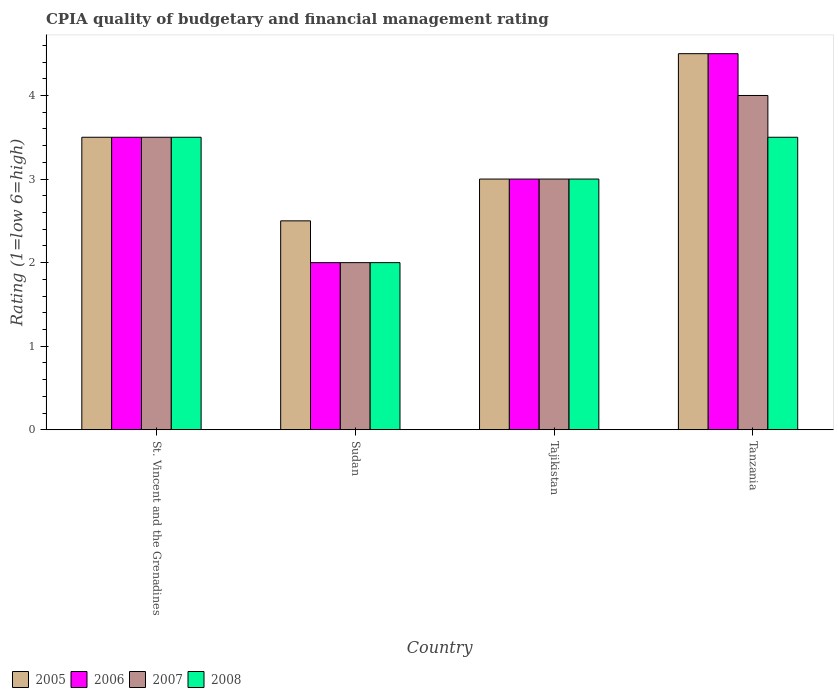How many different coloured bars are there?
Your answer should be compact. 4. How many groups of bars are there?
Your answer should be very brief. 4. Are the number of bars per tick equal to the number of legend labels?
Give a very brief answer. Yes. Are the number of bars on each tick of the X-axis equal?
Give a very brief answer. Yes. How many bars are there on the 2nd tick from the left?
Your answer should be very brief. 4. What is the label of the 1st group of bars from the left?
Provide a short and direct response. St. Vincent and the Grenadines. What is the CPIA rating in 2006 in Tajikistan?
Ensure brevity in your answer.  3. Across all countries, what is the maximum CPIA rating in 2007?
Your answer should be very brief. 4. Across all countries, what is the minimum CPIA rating in 2007?
Your answer should be very brief. 2. In which country was the CPIA rating in 2008 maximum?
Offer a very short reply. St. Vincent and the Grenadines. In which country was the CPIA rating in 2008 minimum?
Your answer should be very brief. Sudan. What is the total CPIA rating in 2008 in the graph?
Ensure brevity in your answer.  12. What is the difference between the CPIA rating in 2006 in Sudan and that in Tajikistan?
Provide a short and direct response. -1. What is the average CPIA rating in 2008 per country?
Your response must be concise. 3. What is the difference between the CPIA rating of/in 2008 and CPIA rating of/in 2006 in Tajikistan?
Your answer should be very brief. 0. In how many countries, is the CPIA rating in 2005 greater than 1.8?
Give a very brief answer. 4. What is the ratio of the CPIA rating in 2006 in Sudan to that in Tajikistan?
Keep it short and to the point. 0.67. Is the difference between the CPIA rating in 2008 in Sudan and Tanzania greater than the difference between the CPIA rating in 2006 in Sudan and Tanzania?
Give a very brief answer. Yes. What is the difference between the highest and the lowest CPIA rating in 2007?
Keep it short and to the point. 2. What does the 4th bar from the left in Sudan represents?
Your answer should be very brief. 2008. What does the 2nd bar from the right in St. Vincent and the Grenadines represents?
Provide a succinct answer. 2007. How many bars are there?
Make the answer very short. 16. What is the difference between two consecutive major ticks on the Y-axis?
Provide a short and direct response. 1. Are the values on the major ticks of Y-axis written in scientific E-notation?
Your answer should be compact. No. Does the graph contain grids?
Offer a terse response. No. Where does the legend appear in the graph?
Make the answer very short. Bottom left. How many legend labels are there?
Keep it short and to the point. 4. What is the title of the graph?
Ensure brevity in your answer.  CPIA quality of budgetary and financial management rating. Does "1993" appear as one of the legend labels in the graph?
Your answer should be very brief. No. What is the label or title of the X-axis?
Offer a terse response. Country. What is the Rating (1=low 6=high) of 2006 in St. Vincent and the Grenadines?
Ensure brevity in your answer.  3.5. What is the Rating (1=low 6=high) in 2007 in St. Vincent and the Grenadines?
Provide a succinct answer. 3.5. What is the Rating (1=low 6=high) in 2005 in Sudan?
Provide a succinct answer. 2.5. What is the Rating (1=low 6=high) of 2006 in Sudan?
Your answer should be very brief. 2. What is the Rating (1=low 6=high) of 2007 in Sudan?
Offer a very short reply. 2. What is the Rating (1=low 6=high) in 2008 in Sudan?
Your answer should be very brief. 2. What is the Rating (1=low 6=high) of 2005 in Tajikistan?
Provide a short and direct response. 3. What is the Rating (1=low 6=high) of 2006 in Tajikistan?
Offer a terse response. 3. What is the Rating (1=low 6=high) of 2008 in Tajikistan?
Your response must be concise. 3. What is the Rating (1=low 6=high) in 2006 in Tanzania?
Offer a very short reply. 4.5. What is the Rating (1=low 6=high) in 2007 in Tanzania?
Give a very brief answer. 4. What is the Rating (1=low 6=high) in 2008 in Tanzania?
Make the answer very short. 3.5. Across all countries, what is the maximum Rating (1=low 6=high) in 2006?
Provide a succinct answer. 4.5. Across all countries, what is the maximum Rating (1=low 6=high) of 2008?
Your response must be concise. 3.5. Across all countries, what is the minimum Rating (1=low 6=high) of 2005?
Ensure brevity in your answer.  2.5. Across all countries, what is the minimum Rating (1=low 6=high) in 2006?
Provide a succinct answer. 2. What is the total Rating (1=low 6=high) of 2007 in the graph?
Make the answer very short. 12.5. What is the difference between the Rating (1=low 6=high) in 2005 in St. Vincent and the Grenadines and that in Sudan?
Make the answer very short. 1. What is the difference between the Rating (1=low 6=high) of 2007 in St. Vincent and the Grenadines and that in Sudan?
Offer a very short reply. 1.5. What is the difference between the Rating (1=low 6=high) of 2008 in St. Vincent and the Grenadines and that in Sudan?
Your answer should be compact. 1.5. What is the difference between the Rating (1=low 6=high) in 2005 in St. Vincent and the Grenadines and that in Tajikistan?
Provide a succinct answer. 0.5. What is the difference between the Rating (1=low 6=high) of 2007 in St. Vincent and the Grenadines and that in Tajikistan?
Make the answer very short. 0.5. What is the difference between the Rating (1=low 6=high) in 2008 in St. Vincent and the Grenadines and that in Tajikistan?
Keep it short and to the point. 0.5. What is the difference between the Rating (1=low 6=high) of 2006 in St. Vincent and the Grenadines and that in Tanzania?
Give a very brief answer. -1. What is the difference between the Rating (1=low 6=high) in 2005 in Sudan and that in Tajikistan?
Ensure brevity in your answer.  -0.5. What is the difference between the Rating (1=low 6=high) of 2007 in Sudan and that in Tajikistan?
Offer a very short reply. -1. What is the difference between the Rating (1=low 6=high) in 2008 in Sudan and that in Tajikistan?
Your answer should be very brief. -1. What is the difference between the Rating (1=low 6=high) in 2005 in Sudan and that in Tanzania?
Make the answer very short. -2. What is the difference between the Rating (1=low 6=high) in 2006 in Sudan and that in Tanzania?
Provide a succinct answer. -2.5. What is the difference between the Rating (1=low 6=high) of 2007 in Sudan and that in Tanzania?
Your response must be concise. -2. What is the difference between the Rating (1=low 6=high) of 2008 in Sudan and that in Tanzania?
Keep it short and to the point. -1.5. What is the difference between the Rating (1=low 6=high) of 2006 in Tajikistan and that in Tanzania?
Provide a short and direct response. -1.5. What is the difference between the Rating (1=low 6=high) in 2007 in Tajikistan and that in Tanzania?
Provide a succinct answer. -1. What is the difference between the Rating (1=low 6=high) of 2008 in Tajikistan and that in Tanzania?
Your response must be concise. -0.5. What is the difference between the Rating (1=low 6=high) of 2005 in St. Vincent and the Grenadines and the Rating (1=low 6=high) of 2006 in Sudan?
Keep it short and to the point. 1.5. What is the difference between the Rating (1=low 6=high) in 2005 in St. Vincent and the Grenadines and the Rating (1=low 6=high) in 2007 in Sudan?
Offer a very short reply. 1.5. What is the difference between the Rating (1=low 6=high) of 2005 in St. Vincent and the Grenadines and the Rating (1=low 6=high) of 2008 in Sudan?
Provide a succinct answer. 1.5. What is the difference between the Rating (1=low 6=high) in 2006 in St. Vincent and the Grenadines and the Rating (1=low 6=high) in 2008 in Sudan?
Keep it short and to the point. 1.5. What is the difference between the Rating (1=low 6=high) in 2007 in St. Vincent and the Grenadines and the Rating (1=low 6=high) in 2008 in Sudan?
Provide a short and direct response. 1.5. What is the difference between the Rating (1=low 6=high) in 2005 in St. Vincent and the Grenadines and the Rating (1=low 6=high) in 2007 in Tajikistan?
Give a very brief answer. 0.5. What is the difference between the Rating (1=low 6=high) in 2005 in St. Vincent and the Grenadines and the Rating (1=low 6=high) in 2008 in Tajikistan?
Ensure brevity in your answer.  0.5. What is the difference between the Rating (1=low 6=high) in 2006 in St. Vincent and the Grenadines and the Rating (1=low 6=high) in 2007 in Tajikistan?
Give a very brief answer. 0.5. What is the difference between the Rating (1=low 6=high) in 2006 in St. Vincent and the Grenadines and the Rating (1=low 6=high) in 2008 in Tajikistan?
Ensure brevity in your answer.  0.5. What is the difference between the Rating (1=low 6=high) in 2005 in St. Vincent and the Grenadines and the Rating (1=low 6=high) in 2006 in Tanzania?
Provide a short and direct response. -1. What is the difference between the Rating (1=low 6=high) of 2005 in St. Vincent and the Grenadines and the Rating (1=low 6=high) of 2008 in Tanzania?
Offer a terse response. 0. What is the difference between the Rating (1=low 6=high) of 2006 in St. Vincent and the Grenadines and the Rating (1=low 6=high) of 2007 in Tanzania?
Provide a succinct answer. -0.5. What is the difference between the Rating (1=low 6=high) of 2006 in St. Vincent and the Grenadines and the Rating (1=low 6=high) of 2008 in Tanzania?
Offer a very short reply. 0. What is the difference between the Rating (1=low 6=high) in 2007 in St. Vincent and the Grenadines and the Rating (1=low 6=high) in 2008 in Tanzania?
Offer a terse response. 0. What is the difference between the Rating (1=low 6=high) in 2005 in Sudan and the Rating (1=low 6=high) in 2006 in Tajikistan?
Ensure brevity in your answer.  -0.5. What is the difference between the Rating (1=low 6=high) of 2005 in Sudan and the Rating (1=low 6=high) of 2008 in Tajikistan?
Offer a terse response. -0.5. What is the difference between the Rating (1=low 6=high) of 2006 in Sudan and the Rating (1=low 6=high) of 2007 in Tajikistan?
Offer a terse response. -1. What is the difference between the Rating (1=low 6=high) of 2005 in Sudan and the Rating (1=low 6=high) of 2006 in Tanzania?
Your answer should be very brief. -2. What is the difference between the Rating (1=low 6=high) in 2007 in Sudan and the Rating (1=low 6=high) in 2008 in Tanzania?
Offer a very short reply. -1.5. What is the difference between the Rating (1=low 6=high) of 2005 in Tajikistan and the Rating (1=low 6=high) of 2006 in Tanzania?
Offer a very short reply. -1.5. What is the difference between the Rating (1=low 6=high) in 2005 in Tajikistan and the Rating (1=low 6=high) in 2008 in Tanzania?
Give a very brief answer. -0.5. What is the difference between the Rating (1=low 6=high) in 2007 in Tajikistan and the Rating (1=low 6=high) in 2008 in Tanzania?
Keep it short and to the point. -0.5. What is the average Rating (1=low 6=high) of 2005 per country?
Ensure brevity in your answer.  3.38. What is the average Rating (1=low 6=high) of 2006 per country?
Your answer should be compact. 3.25. What is the average Rating (1=low 6=high) in 2007 per country?
Provide a short and direct response. 3.12. What is the average Rating (1=low 6=high) of 2008 per country?
Make the answer very short. 3. What is the difference between the Rating (1=low 6=high) of 2005 and Rating (1=low 6=high) of 2006 in St. Vincent and the Grenadines?
Offer a terse response. 0. What is the difference between the Rating (1=low 6=high) in 2006 and Rating (1=low 6=high) in 2007 in St. Vincent and the Grenadines?
Your response must be concise. 0. What is the difference between the Rating (1=low 6=high) of 2006 and Rating (1=low 6=high) of 2008 in St. Vincent and the Grenadines?
Keep it short and to the point. 0. What is the difference between the Rating (1=low 6=high) of 2005 and Rating (1=low 6=high) of 2007 in Sudan?
Provide a succinct answer. 0.5. What is the difference between the Rating (1=low 6=high) of 2005 and Rating (1=low 6=high) of 2008 in Sudan?
Provide a short and direct response. 0.5. What is the difference between the Rating (1=low 6=high) of 2006 and Rating (1=low 6=high) of 2007 in Sudan?
Your response must be concise. 0. What is the difference between the Rating (1=low 6=high) in 2006 and Rating (1=low 6=high) in 2008 in Sudan?
Offer a very short reply. 0. What is the difference between the Rating (1=low 6=high) of 2007 and Rating (1=low 6=high) of 2008 in Sudan?
Offer a terse response. 0. What is the difference between the Rating (1=low 6=high) of 2005 and Rating (1=low 6=high) of 2006 in Tajikistan?
Provide a succinct answer. 0. What is the difference between the Rating (1=low 6=high) in 2006 and Rating (1=low 6=high) in 2008 in Tajikistan?
Offer a very short reply. 0. What is the difference between the Rating (1=low 6=high) of 2006 and Rating (1=low 6=high) of 2008 in Tanzania?
Your response must be concise. 1. What is the difference between the Rating (1=low 6=high) of 2007 and Rating (1=low 6=high) of 2008 in Tanzania?
Offer a terse response. 0.5. What is the ratio of the Rating (1=low 6=high) in 2006 in St. Vincent and the Grenadines to that in Sudan?
Give a very brief answer. 1.75. What is the ratio of the Rating (1=low 6=high) of 2007 in St. Vincent and the Grenadines to that in Sudan?
Your answer should be compact. 1.75. What is the ratio of the Rating (1=low 6=high) of 2006 in St. Vincent and the Grenadines to that in Tajikistan?
Provide a short and direct response. 1.17. What is the ratio of the Rating (1=low 6=high) of 2007 in St. Vincent and the Grenadines to that in Tajikistan?
Your response must be concise. 1.17. What is the ratio of the Rating (1=low 6=high) in 2008 in St. Vincent and the Grenadines to that in Tajikistan?
Keep it short and to the point. 1.17. What is the ratio of the Rating (1=low 6=high) of 2006 in Sudan to that in Tajikistan?
Offer a very short reply. 0.67. What is the ratio of the Rating (1=low 6=high) in 2007 in Sudan to that in Tajikistan?
Keep it short and to the point. 0.67. What is the ratio of the Rating (1=low 6=high) in 2008 in Sudan to that in Tajikistan?
Your response must be concise. 0.67. What is the ratio of the Rating (1=low 6=high) of 2005 in Sudan to that in Tanzania?
Provide a succinct answer. 0.56. What is the ratio of the Rating (1=low 6=high) in 2006 in Sudan to that in Tanzania?
Give a very brief answer. 0.44. What is the ratio of the Rating (1=low 6=high) of 2006 in Tajikistan to that in Tanzania?
Offer a terse response. 0.67. What is the difference between the highest and the second highest Rating (1=low 6=high) of 2005?
Ensure brevity in your answer.  1. What is the difference between the highest and the second highest Rating (1=low 6=high) in 2007?
Provide a succinct answer. 0.5. What is the difference between the highest and the lowest Rating (1=low 6=high) of 2006?
Provide a succinct answer. 2.5. What is the difference between the highest and the lowest Rating (1=low 6=high) of 2008?
Provide a short and direct response. 1.5. 